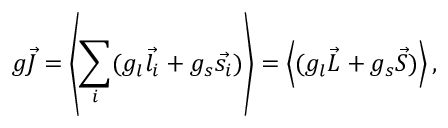Convert formula to latex. <formula><loc_0><loc_0><loc_500><loc_500>g { \vec { J } } = \left \langle \sum _ { i } ( g _ { l } { \vec { l _ { i } } } + g _ { s } { \vec { s _ { i } } } ) \right \rangle = \left \langle ( g _ { l } { \vec { L } } + g _ { s } { \vec { S } } ) \right \rangle ,</formula> 